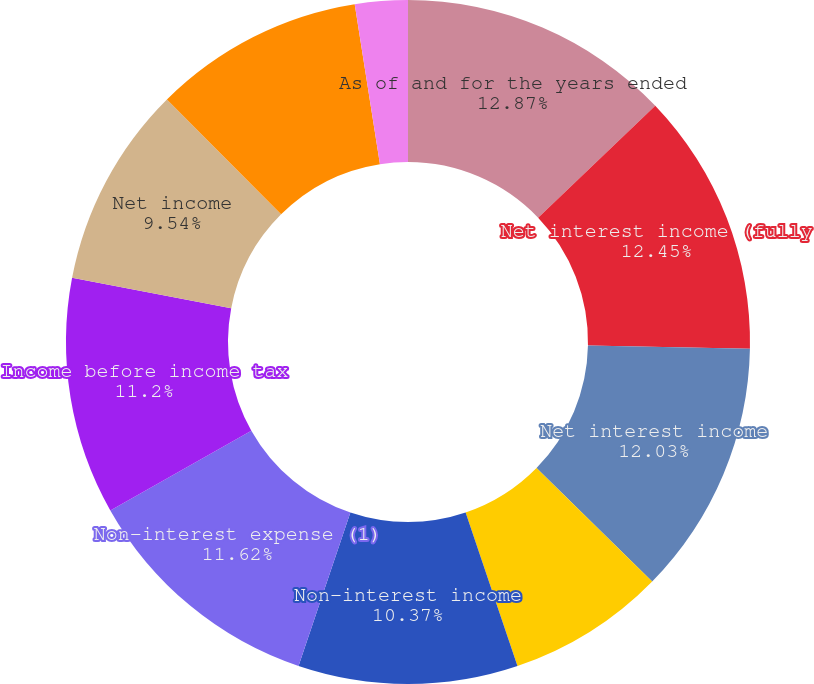<chart> <loc_0><loc_0><loc_500><loc_500><pie_chart><fcel>As of and for the years ended<fcel>Net interest income (fully<fcel>Net interest income<fcel>Provision for loan losses<fcel>Non-interest income<fcel>Non-interest expense (1)<fcel>Income before income tax<fcel>Net income<fcel>Net income available to common<fcel>Net interest margin<nl><fcel>12.86%<fcel>12.45%<fcel>12.03%<fcel>7.47%<fcel>10.37%<fcel>11.62%<fcel>11.2%<fcel>9.54%<fcel>9.96%<fcel>2.49%<nl></chart> 